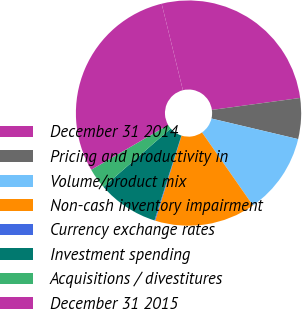<chart> <loc_0><loc_0><loc_500><loc_500><pie_chart><fcel>December 31 2014<fcel>Pricing and productivity in<fcel>Volume/product mix<fcel>Non-cash inventory impairment<fcel>Currency exchange rates<fcel>Investment spending<fcel>Acquisitions / divestitures<fcel>December 31 2015<nl><fcel>26.69%<fcel>5.85%<fcel>11.6%<fcel>14.47%<fcel>0.11%<fcel>8.73%<fcel>2.98%<fcel>29.56%<nl></chart> 